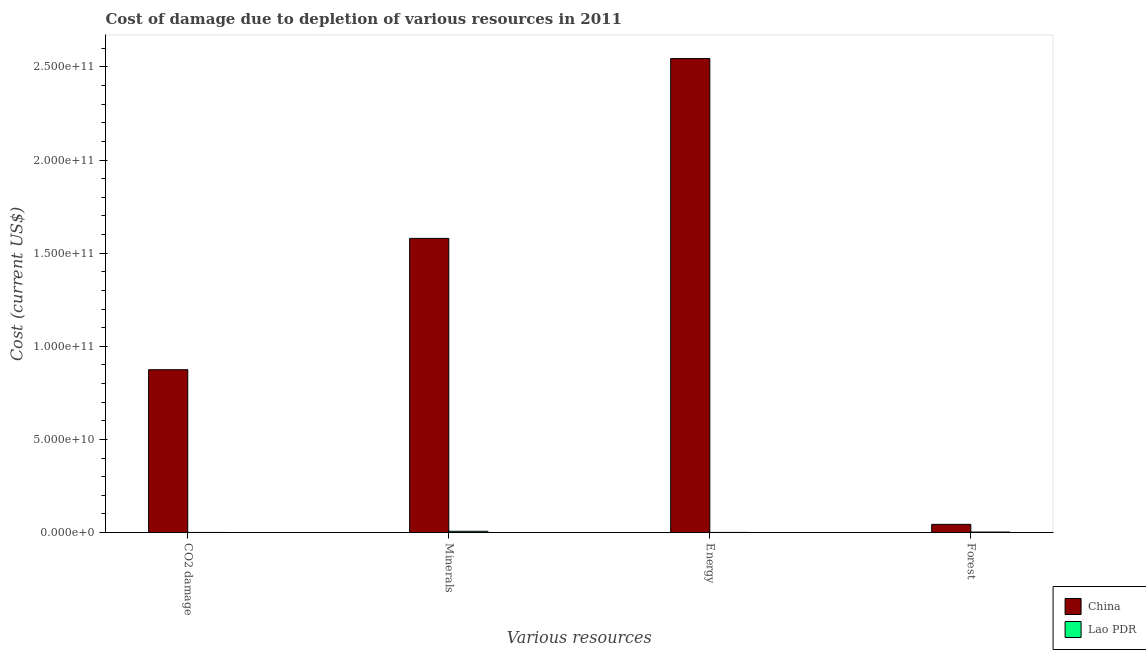How many different coloured bars are there?
Your answer should be compact. 2. How many groups of bars are there?
Keep it short and to the point. 4. Are the number of bars on each tick of the X-axis equal?
Provide a succinct answer. Yes. How many bars are there on the 2nd tick from the right?
Offer a very short reply. 2. What is the label of the 1st group of bars from the left?
Your response must be concise. CO2 damage. What is the cost of damage due to depletion of forests in Lao PDR?
Make the answer very short. 2.25e+08. Across all countries, what is the maximum cost of damage due to depletion of forests?
Make the answer very short. 4.36e+09. Across all countries, what is the minimum cost of damage due to depletion of minerals?
Provide a succinct answer. 6.51e+08. In which country was the cost of damage due to depletion of minerals minimum?
Provide a succinct answer. Lao PDR. What is the total cost of damage due to depletion of minerals in the graph?
Provide a short and direct response. 1.59e+11. What is the difference between the cost of damage due to depletion of coal in Lao PDR and that in China?
Make the answer very short. -8.74e+1. What is the difference between the cost of damage due to depletion of minerals in China and the cost of damage due to depletion of coal in Lao PDR?
Provide a succinct answer. 1.58e+11. What is the average cost of damage due to depletion of coal per country?
Your response must be concise. 4.37e+1. What is the difference between the cost of damage due to depletion of energy and cost of damage due to depletion of minerals in Lao PDR?
Your response must be concise. -6.21e+08. What is the ratio of the cost of damage due to depletion of forests in China to that in Lao PDR?
Offer a very short reply. 19.36. What is the difference between the highest and the second highest cost of damage due to depletion of coal?
Offer a very short reply. 8.74e+1. What is the difference between the highest and the lowest cost of damage due to depletion of energy?
Keep it short and to the point. 2.54e+11. In how many countries, is the cost of damage due to depletion of coal greater than the average cost of damage due to depletion of coal taken over all countries?
Make the answer very short. 1. Is it the case that in every country, the sum of the cost of damage due to depletion of coal and cost of damage due to depletion of forests is greater than the sum of cost of damage due to depletion of energy and cost of damage due to depletion of minerals?
Give a very brief answer. No. What does the 2nd bar from the left in Minerals represents?
Your answer should be compact. Lao PDR. What does the 1st bar from the right in Minerals represents?
Provide a succinct answer. Lao PDR. Are all the bars in the graph horizontal?
Ensure brevity in your answer.  No. How many countries are there in the graph?
Provide a short and direct response. 2. What is the difference between two consecutive major ticks on the Y-axis?
Your response must be concise. 5.00e+1. Does the graph contain grids?
Your answer should be very brief. No. Where does the legend appear in the graph?
Offer a very short reply. Bottom right. How are the legend labels stacked?
Provide a succinct answer. Vertical. What is the title of the graph?
Keep it short and to the point. Cost of damage due to depletion of various resources in 2011 . What is the label or title of the X-axis?
Provide a short and direct response. Various resources. What is the label or title of the Y-axis?
Make the answer very short. Cost (current US$). What is the Cost (current US$) of China in CO2 damage?
Your response must be concise. 8.74e+1. What is the Cost (current US$) of Lao PDR in CO2 damage?
Give a very brief answer. 1.17e+07. What is the Cost (current US$) of China in Minerals?
Offer a very short reply. 1.58e+11. What is the Cost (current US$) in Lao PDR in Minerals?
Keep it short and to the point. 6.51e+08. What is the Cost (current US$) in China in Energy?
Your response must be concise. 2.55e+11. What is the Cost (current US$) in Lao PDR in Energy?
Offer a very short reply. 2.95e+07. What is the Cost (current US$) in China in Forest?
Ensure brevity in your answer.  4.36e+09. What is the Cost (current US$) of Lao PDR in Forest?
Your answer should be very brief. 2.25e+08. Across all Various resources, what is the maximum Cost (current US$) in China?
Your response must be concise. 2.55e+11. Across all Various resources, what is the maximum Cost (current US$) of Lao PDR?
Your response must be concise. 6.51e+08. Across all Various resources, what is the minimum Cost (current US$) of China?
Keep it short and to the point. 4.36e+09. Across all Various resources, what is the minimum Cost (current US$) of Lao PDR?
Provide a short and direct response. 1.17e+07. What is the total Cost (current US$) in China in the graph?
Your response must be concise. 5.04e+11. What is the total Cost (current US$) in Lao PDR in the graph?
Your answer should be compact. 9.17e+08. What is the difference between the Cost (current US$) of China in CO2 damage and that in Minerals?
Offer a terse response. -7.05e+1. What is the difference between the Cost (current US$) of Lao PDR in CO2 damage and that in Minerals?
Give a very brief answer. -6.39e+08. What is the difference between the Cost (current US$) in China in CO2 damage and that in Energy?
Provide a succinct answer. -1.67e+11. What is the difference between the Cost (current US$) in Lao PDR in CO2 damage and that in Energy?
Give a very brief answer. -1.79e+07. What is the difference between the Cost (current US$) in China in CO2 damage and that in Forest?
Your response must be concise. 8.31e+1. What is the difference between the Cost (current US$) in Lao PDR in CO2 damage and that in Forest?
Provide a succinct answer. -2.14e+08. What is the difference between the Cost (current US$) of China in Minerals and that in Energy?
Provide a short and direct response. -9.66e+1. What is the difference between the Cost (current US$) in Lao PDR in Minerals and that in Energy?
Keep it short and to the point. 6.21e+08. What is the difference between the Cost (current US$) of China in Minerals and that in Forest?
Make the answer very short. 1.54e+11. What is the difference between the Cost (current US$) of Lao PDR in Minerals and that in Forest?
Provide a succinct answer. 4.25e+08. What is the difference between the Cost (current US$) in China in Energy and that in Forest?
Your answer should be compact. 2.50e+11. What is the difference between the Cost (current US$) of Lao PDR in Energy and that in Forest?
Make the answer very short. -1.96e+08. What is the difference between the Cost (current US$) of China in CO2 damage and the Cost (current US$) of Lao PDR in Minerals?
Offer a very short reply. 8.68e+1. What is the difference between the Cost (current US$) in China in CO2 damage and the Cost (current US$) in Lao PDR in Energy?
Provide a succinct answer. 8.74e+1. What is the difference between the Cost (current US$) in China in CO2 damage and the Cost (current US$) in Lao PDR in Forest?
Keep it short and to the point. 8.72e+1. What is the difference between the Cost (current US$) of China in Minerals and the Cost (current US$) of Lao PDR in Energy?
Offer a very short reply. 1.58e+11. What is the difference between the Cost (current US$) of China in Minerals and the Cost (current US$) of Lao PDR in Forest?
Give a very brief answer. 1.58e+11. What is the difference between the Cost (current US$) in China in Energy and the Cost (current US$) in Lao PDR in Forest?
Offer a very short reply. 2.54e+11. What is the average Cost (current US$) of China per Various resources?
Make the answer very short. 1.26e+11. What is the average Cost (current US$) in Lao PDR per Various resources?
Offer a very short reply. 2.29e+08. What is the difference between the Cost (current US$) in China and Cost (current US$) in Lao PDR in CO2 damage?
Provide a succinct answer. 8.74e+1. What is the difference between the Cost (current US$) in China and Cost (current US$) in Lao PDR in Minerals?
Keep it short and to the point. 1.57e+11. What is the difference between the Cost (current US$) of China and Cost (current US$) of Lao PDR in Energy?
Provide a short and direct response. 2.54e+11. What is the difference between the Cost (current US$) of China and Cost (current US$) of Lao PDR in Forest?
Keep it short and to the point. 4.14e+09. What is the ratio of the Cost (current US$) in China in CO2 damage to that in Minerals?
Your answer should be very brief. 0.55. What is the ratio of the Cost (current US$) in Lao PDR in CO2 damage to that in Minerals?
Offer a terse response. 0.02. What is the ratio of the Cost (current US$) of China in CO2 damage to that in Energy?
Offer a terse response. 0.34. What is the ratio of the Cost (current US$) in Lao PDR in CO2 damage to that in Energy?
Your answer should be compact. 0.39. What is the ratio of the Cost (current US$) in China in CO2 damage to that in Forest?
Your answer should be compact. 20.05. What is the ratio of the Cost (current US$) in Lao PDR in CO2 damage to that in Forest?
Your answer should be compact. 0.05. What is the ratio of the Cost (current US$) of China in Minerals to that in Energy?
Provide a short and direct response. 0.62. What is the ratio of the Cost (current US$) of Lao PDR in Minerals to that in Energy?
Offer a very short reply. 22.04. What is the ratio of the Cost (current US$) in China in Minerals to that in Forest?
Your answer should be very brief. 36.22. What is the ratio of the Cost (current US$) in Lao PDR in Minerals to that in Forest?
Provide a short and direct response. 2.89. What is the ratio of the Cost (current US$) in China in Energy to that in Forest?
Provide a short and direct response. 58.37. What is the ratio of the Cost (current US$) in Lao PDR in Energy to that in Forest?
Ensure brevity in your answer.  0.13. What is the difference between the highest and the second highest Cost (current US$) of China?
Keep it short and to the point. 9.66e+1. What is the difference between the highest and the second highest Cost (current US$) of Lao PDR?
Your answer should be very brief. 4.25e+08. What is the difference between the highest and the lowest Cost (current US$) in China?
Keep it short and to the point. 2.50e+11. What is the difference between the highest and the lowest Cost (current US$) in Lao PDR?
Your answer should be compact. 6.39e+08. 